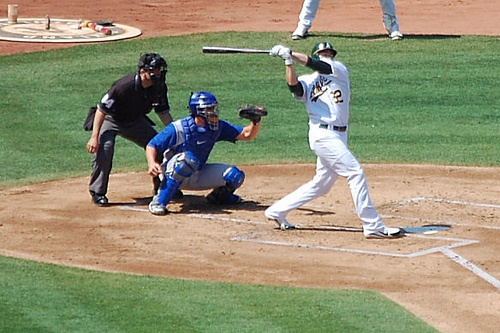Describe the objects in this image and their specific colors. I can see people in salmon, white, darkgray, and black tones, people in salmon, black, navy, gray, and lightgray tones, people in salmon, black, gray, darkgray, and maroon tones, people in salmon, white, darkgray, and gray tones, and baseball glove in salmon, black, gray, and darkgray tones in this image. 